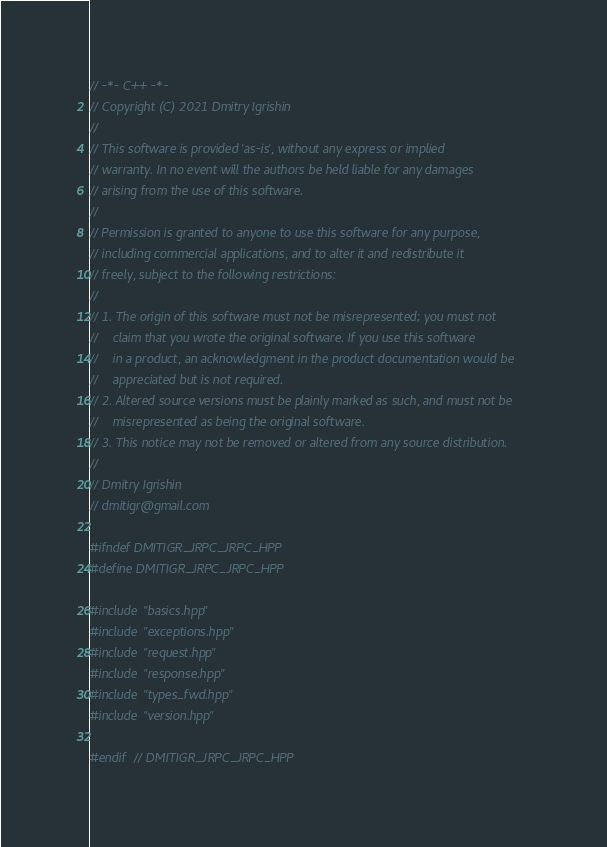Convert code to text. <code><loc_0><loc_0><loc_500><loc_500><_C++_>// -*- C++ -*-
// Copyright (C) 2021 Dmitry Igrishin
//
// This software is provided 'as-is', without any express or implied
// warranty. In no event will the authors be held liable for any damages
// arising from the use of this software.
//
// Permission is granted to anyone to use this software for any purpose,
// including commercial applications, and to alter it and redistribute it
// freely, subject to the following restrictions:
//
// 1. The origin of this software must not be misrepresented; you must not
//    claim that you wrote the original software. If you use this software
//    in a product, an acknowledgment in the product documentation would be
//    appreciated but is not required.
// 2. Altered source versions must be plainly marked as such, and must not be
//    misrepresented as being the original software.
// 3. This notice may not be removed or altered from any source distribution.
//
// Dmitry Igrishin
// dmitigr@gmail.com

#ifndef DMITIGR_JRPC_JRPC_HPP
#define DMITIGR_JRPC_JRPC_HPP

#include "basics.hpp"
#include "exceptions.hpp"
#include "request.hpp"
#include "response.hpp"
#include "types_fwd.hpp"
#include "version.hpp"

#endif  // DMITIGR_JRPC_JRPC_HPP
</code> 